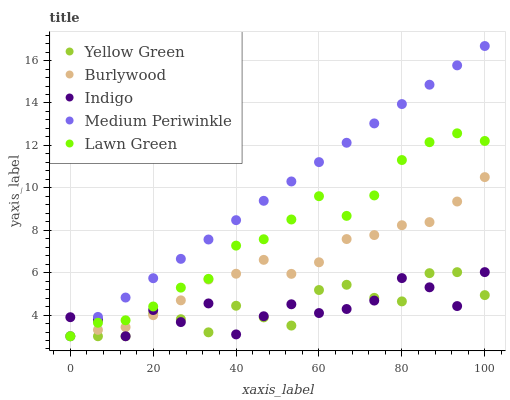Does Indigo have the minimum area under the curve?
Answer yes or no. Yes. Does Medium Periwinkle have the maximum area under the curve?
Answer yes or no. Yes. Does Medium Periwinkle have the minimum area under the curve?
Answer yes or no. No. Does Indigo have the maximum area under the curve?
Answer yes or no. No. Is Medium Periwinkle the smoothest?
Answer yes or no. Yes. Is Indigo the roughest?
Answer yes or no. Yes. Is Indigo the smoothest?
Answer yes or no. No. Is Medium Periwinkle the roughest?
Answer yes or no. No. Does Burlywood have the lowest value?
Answer yes or no. Yes. Does Medium Periwinkle have the highest value?
Answer yes or no. Yes. Does Indigo have the highest value?
Answer yes or no. No. Does Burlywood intersect Medium Periwinkle?
Answer yes or no. Yes. Is Burlywood less than Medium Periwinkle?
Answer yes or no. No. Is Burlywood greater than Medium Periwinkle?
Answer yes or no. No. 